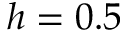<formula> <loc_0><loc_0><loc_500><loc_500>h = 0 . 5</formula> 